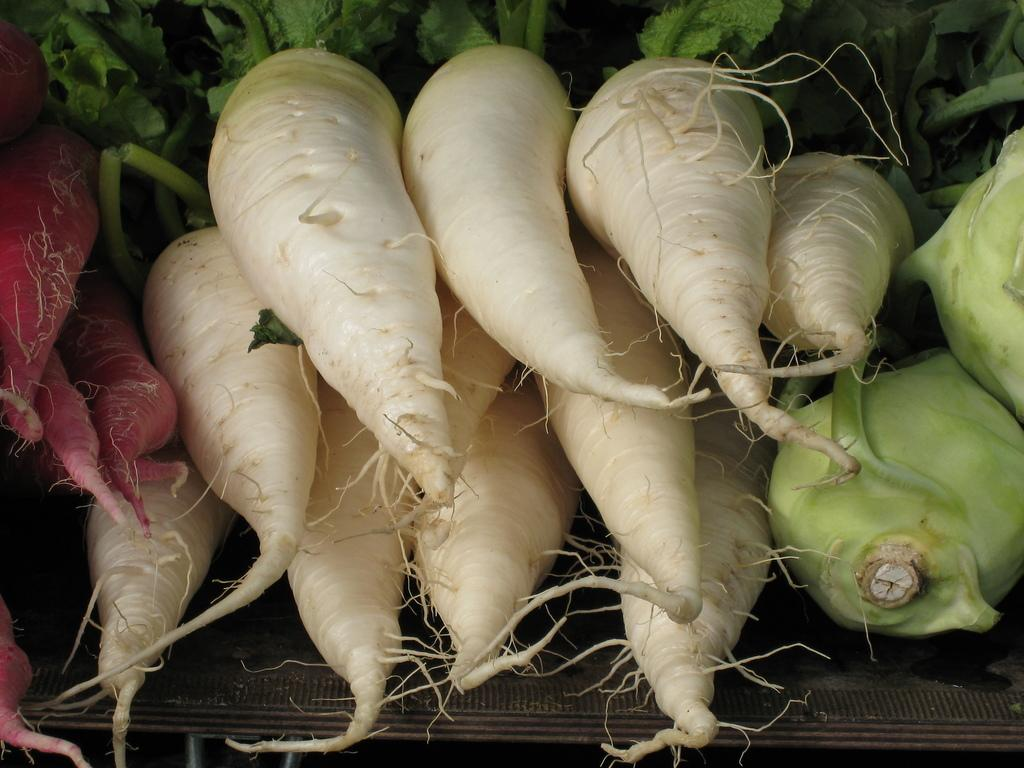What type of vegetable is present in the image? There are carrots in the image. How are the carrots arranged or displayed in the image? The carrots are on a rack in the image. What type of brass instrument can be seen playing in the image? There is no brass instrument present in the image; it only features carrots on a rack. 